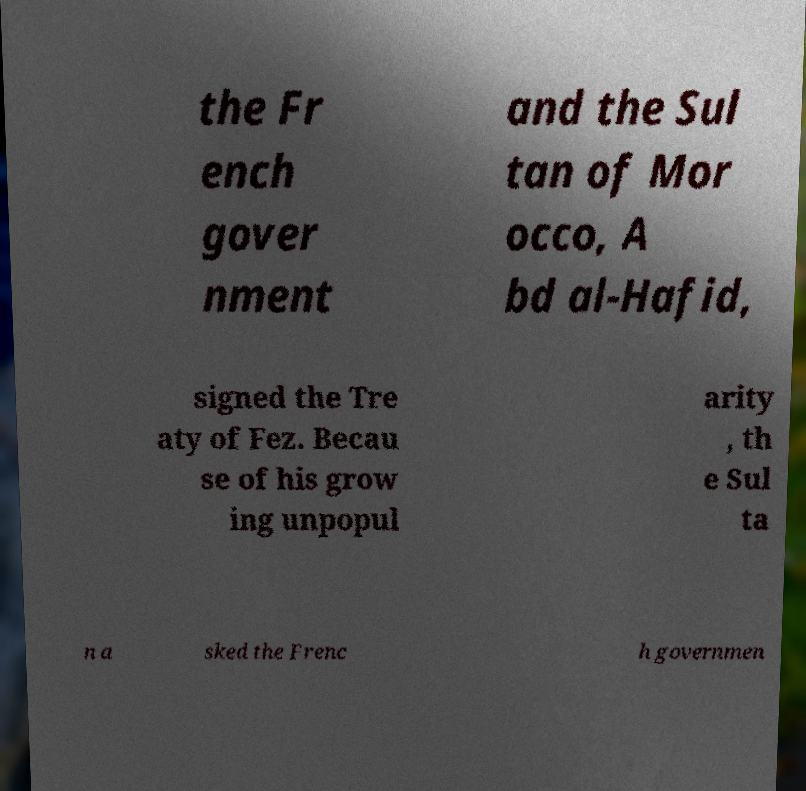Could you extract and type out the text from this image? the Fr ench gover nment and the Sul tan of Mor occo, A bd al-Hafid, signed the Tre aty of Fez. Becau se of his grow ing unpopul arity , th e Sul ta n a sked the Frenc h governmen 